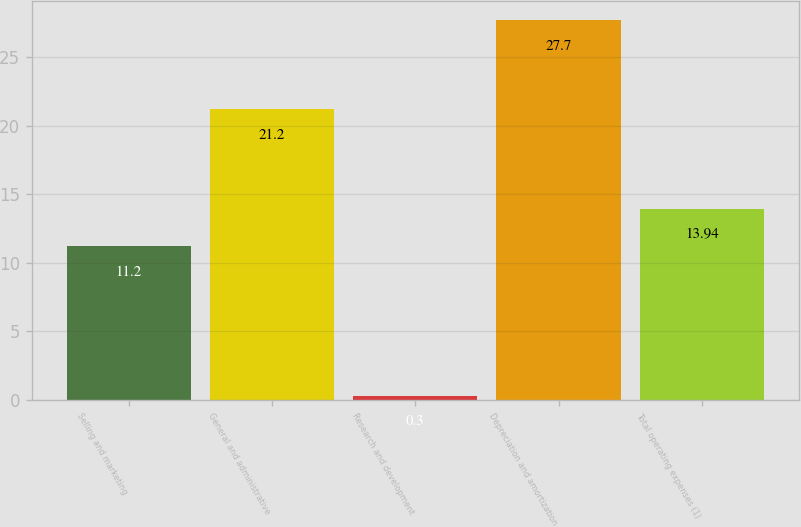Convert chart. <chart><loc_0><loc_0><loc_500><loc_500><bar_chart><fcel>Selling and marketing<fcel>General and administrative<fcel>Research and development<fcel>Depreciation and amortization<fcel>Total operating expenses (1)<nl><fcel>11.2<fcel>21.2<fcel>0.3<fcel>27.7<fcel>13.94<nl></chart> 